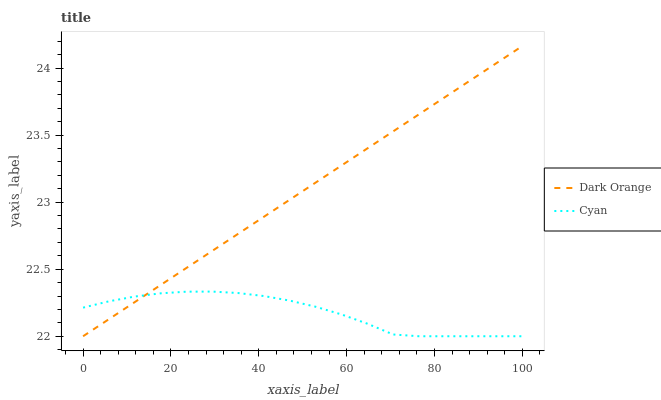Does Cyan have the minimum area under the curve?
Answer yes or no. Yes. Does Dark Orange have the maximum area under the curve?
Answer yes or no. Yes. Does Cyan have the maximum area under the curve?
Answer yes or no. No. Is Dark Orange the smoothest?
Answer yes or no. Yes. Is Cyan the roughest?
Answer yes or no. Yes. Is Cyan the smoothest?
Answer yes or no. No. Does Cyan have the highest value?
Answer yes or no. No. 